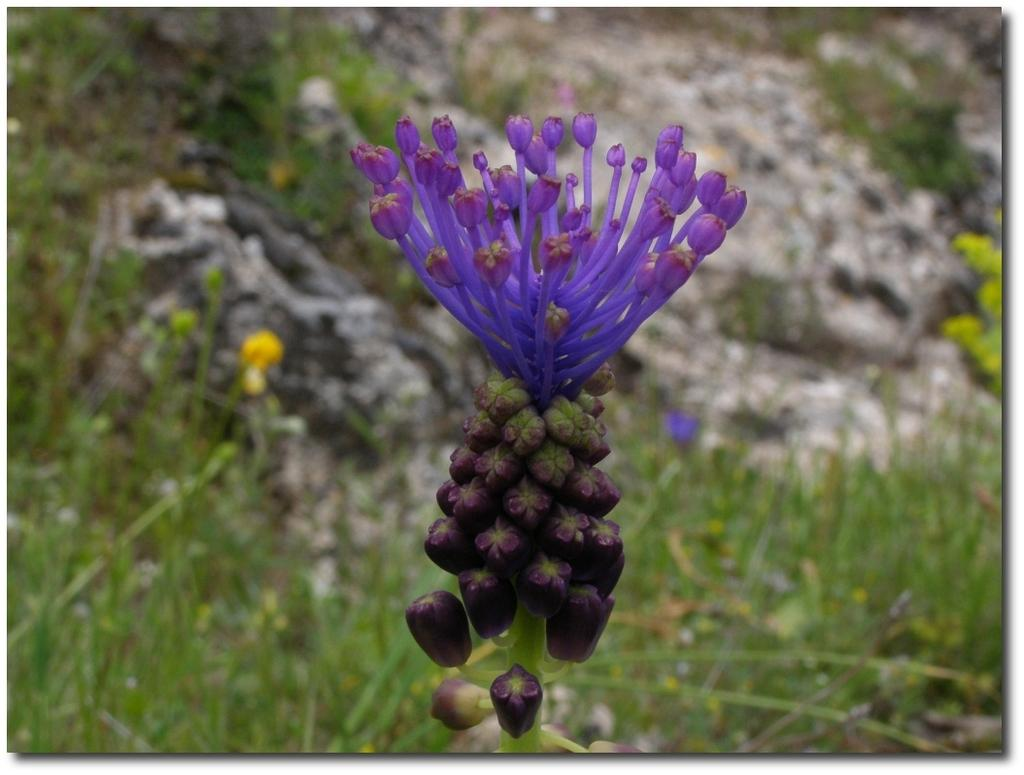What color are the flowers on the plant in the image? The flowers on the plant in the image are violet. How would you describe the background of the image? The background of the image is blurred. What type of vegetation can be seen in the background of the image? Grass and other plants are visible in the background of the image. What type of cakes are being sold at the zoo in the image? There is no mention of cakes or a zoo in the image; it features violet flowers on a plant with a blurred background. 